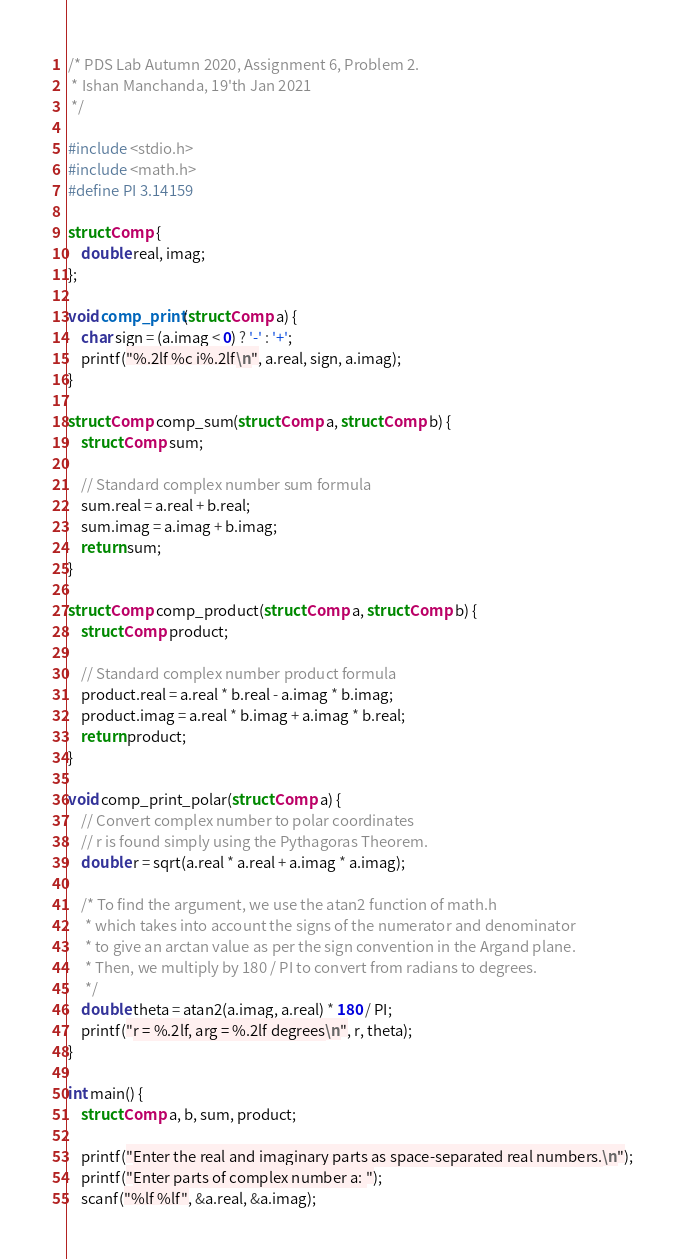Convert code to text. <code><loc_0><loc_0><loc_500><loc_500><_C_>/* PDS Lab Autumn 2020, Assignment 6, Problem 2.
 * Ishan Manchanda, 19'th Jan 2021
 */

#include <stdio.h>
#include <math.h>
#define PI 3.14159

struct Comp {
	double real, imag;
};

void comp_print(struct Comp a) {
	char sign = (a.imag < 0) ? '-' : '+';
	printf("%.2lf %c i%.2lf\n", a.real, sign, a.imag);
}

struct Comp comp_sum(struct Comp a, struct Comp b) {
	struct Comp sum;

	// Standard complex number sum formula
	sum.real = a.real + b.real;
	sum.imag = a.imag + b.imag;
	return sum;
}

struct Comp comp_product(struct Comp a, struct Comp b) {
	struct Comp product;

	// Standard complex number product formula
	product.real = a.real * b.real - a.imag * b.imag;
	product.imag = a.real * b.imag + a.imag * b.real;
	return product;
}

void comp_print_polar(struct Comp a) {
	// Convert complex number to polar coordinates
	// r is found simply using the Pythagoras Theorem.
	double r = sqrt(a.real * a.real + a.imag * a.imag);

	/* To find the argument, we use the atan2 function of math.h
	 * which takes into account the signs of the numerator and denominator
	 * to give an arctan value as per the sign convention in the Argand plane.
	 * Then, we multiply by 180 / PI to convert from radians to degrees.
	 */
	double theta = atan2(a.imag, a.real) * 180 / PI;
	printf("r = %.2lf, arg = %.2lf degrees\n", r, theta);
}

int main() {
	struct Comp a, b, sum, product;

	printf("Enter the real and imaginary parts as space-separated real numbers.\n");
	printf("Enter parts of complex number a: ");
	scanf("%lf %lf", &a.real, &a.imag);
</code> 